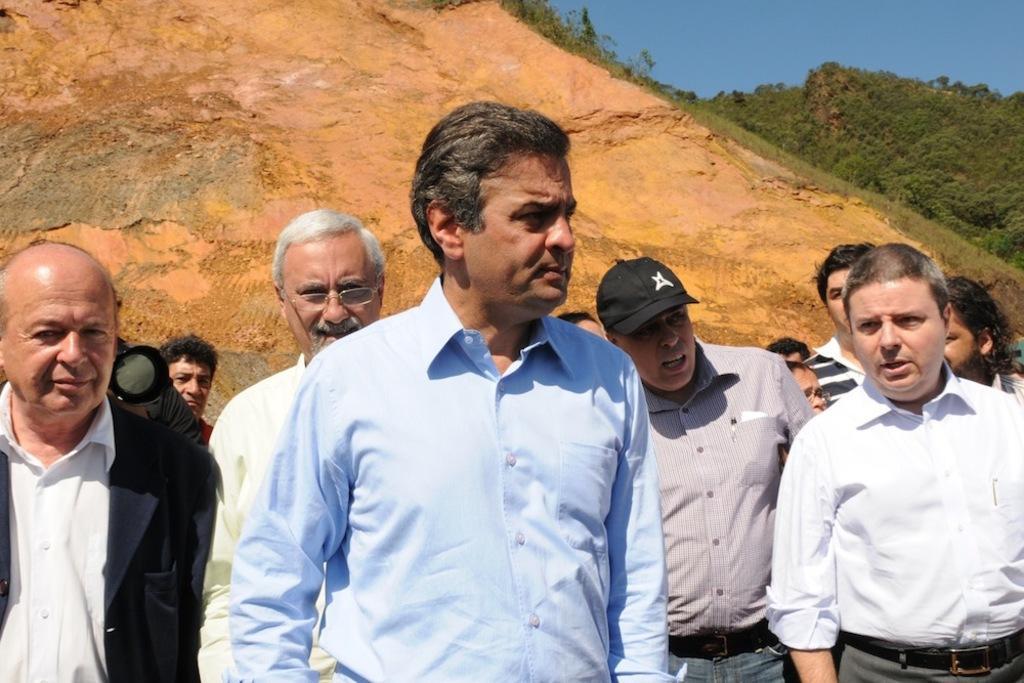Could you give a brief overview of what you see in this image? In this image we can see a group of people standing. In that a person is holding a camera. On the backside we can see a group of trees, the hill and the sky which looks cloudy. 